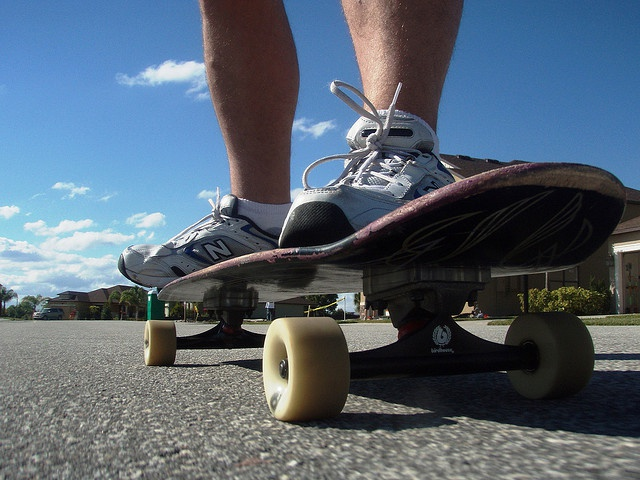Describe the objects in this image and their specific colors. I can see skateboard in gray and black tones, people in gray, black, and darkgray tones, car in gray, black, purple, and darkgray tones, and people in gray, black, darkgray, and darkgreen tones in this image. 